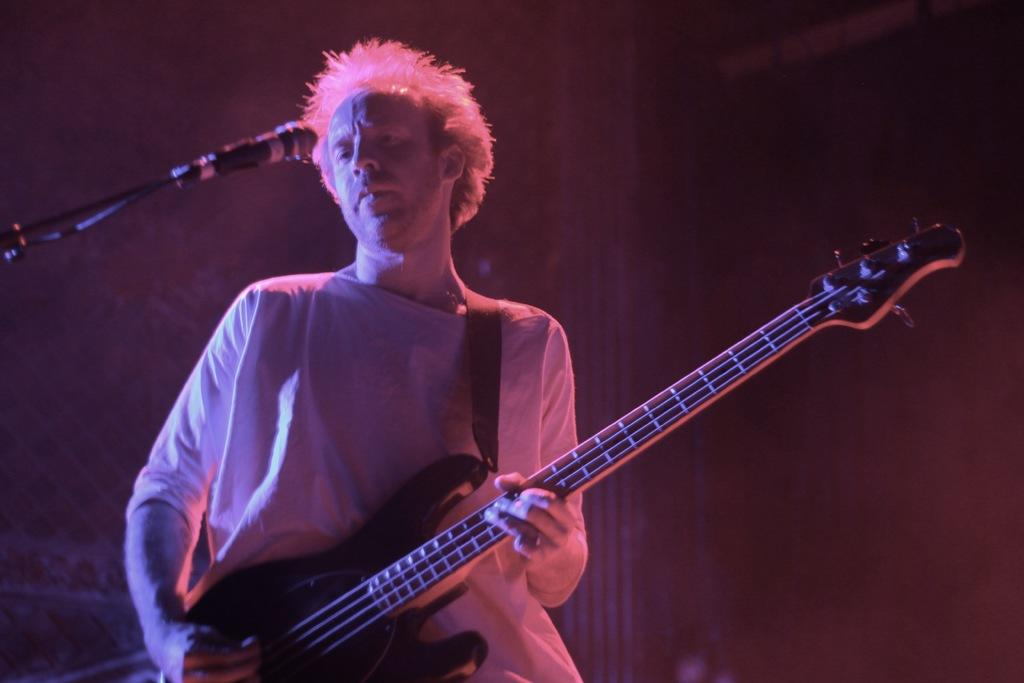What is the man in the image doing? The man is playing the guitar. What object is the man holding while playing the guitar? The man is holding a guitar. What is in front of the man that might be used for amplifying his voice? There is a microphone in front of the man. What can be seen in the background of the image? There is a wall and a pillar in the background of the image. What type of idea is the turkey presenting to the judge in the image? There is no turkey or judge present in the image; it features a man playing the guitar with a microphone in front of him. 